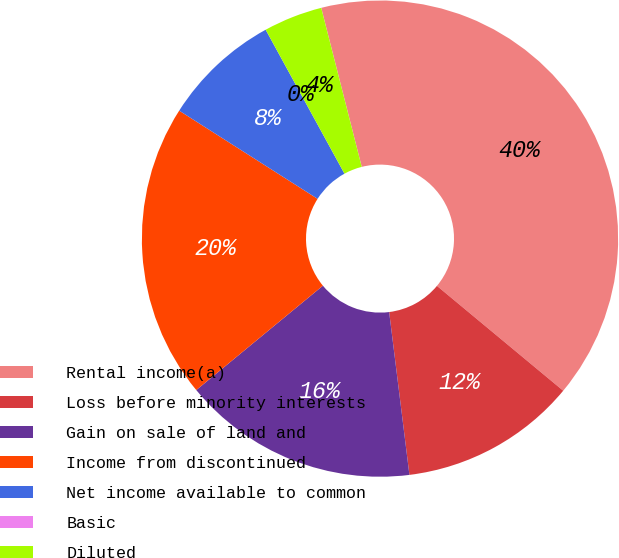Convert chart to OTSL. <chart><loc_0><loc_0><loc_500><loc_500><pie_chart><fcel>Rental income(a)<fcel>Loss before minority interests<fcel>Gain on sale of land and<fcel>Income from discontinued<fcel>Net income available to common<fcel>Basic<fcel>Diluted<nl><fcel>40.0%<fcel>12.0%<fcel>16.0%<fcel>20.0%<fcel>8.0%<fcel>0.0%<fcel>4.0%<nl></chart> 